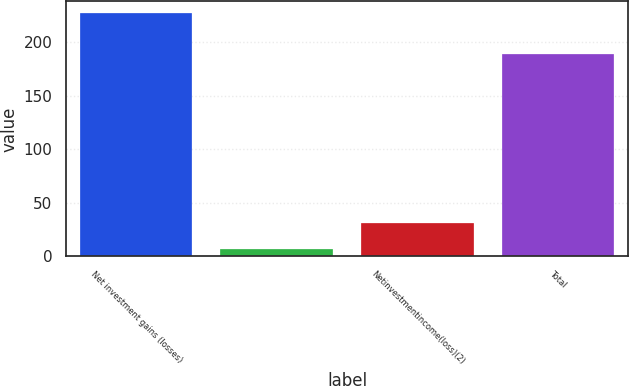Convert chart. <chart><loc_0><loc_0><loc_500><loc_500><bar_chart><fcel>Net investment gains (losses)<fcel>Unnamed: 1<fcel>Netinvestmentincome(loss)(2)<fcel>Total<nl><fcel>227<fcel>7<fcel>31<fcel>189<nl></chart> 